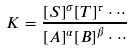<formula> <loc_0><loc_0><loc_500><loc_500>K = \frac { { [ S ] } ^ { \sigma } { [ T ] } ^ { \tau } \cdot \cdot \cdot } { { [ A ] } ^ { \alpha } { [ B ] } ^ { \beta } \cdot \cdot \cdot }</formula> 